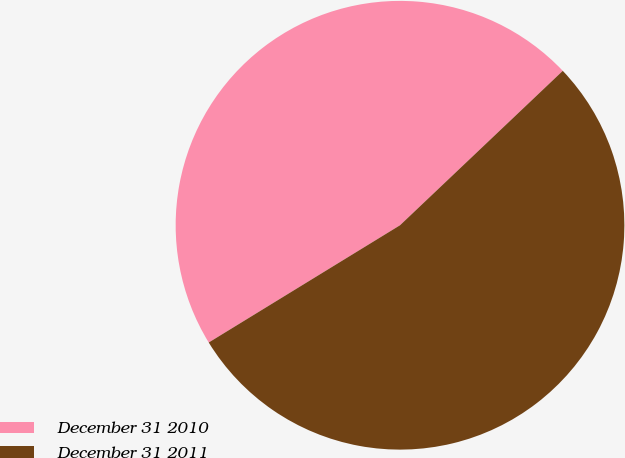Convert chart. <chart><loc_0><loc_0><loc_500><loc_500><pie_chart><fcel>December 31 2010<fcel>December 31 2011<nl><fcel>46.67%<fcel>53.33%<nl></chart> 